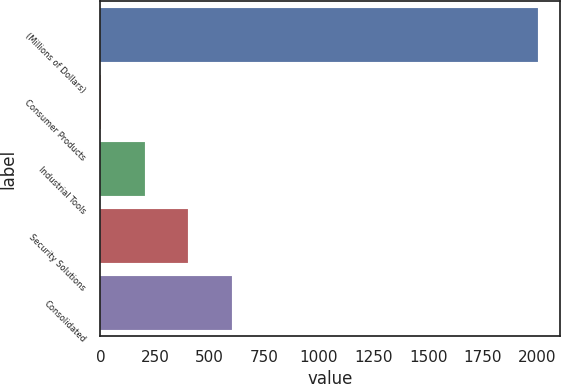Convert chart to OTSL. <chart><loc_0><loc_0><loc_500><loc_500><bar_chart><fcel>(Millions of Dollars)<fcel>Consumer Products<fcel>Industrial Tools<fcel>Security Solutions<fcel>Consolidated<nl><fcel>2004<fcel>1.3<fcel>201.57<fcel>401.84<fcel>602.11<nl></chart> 